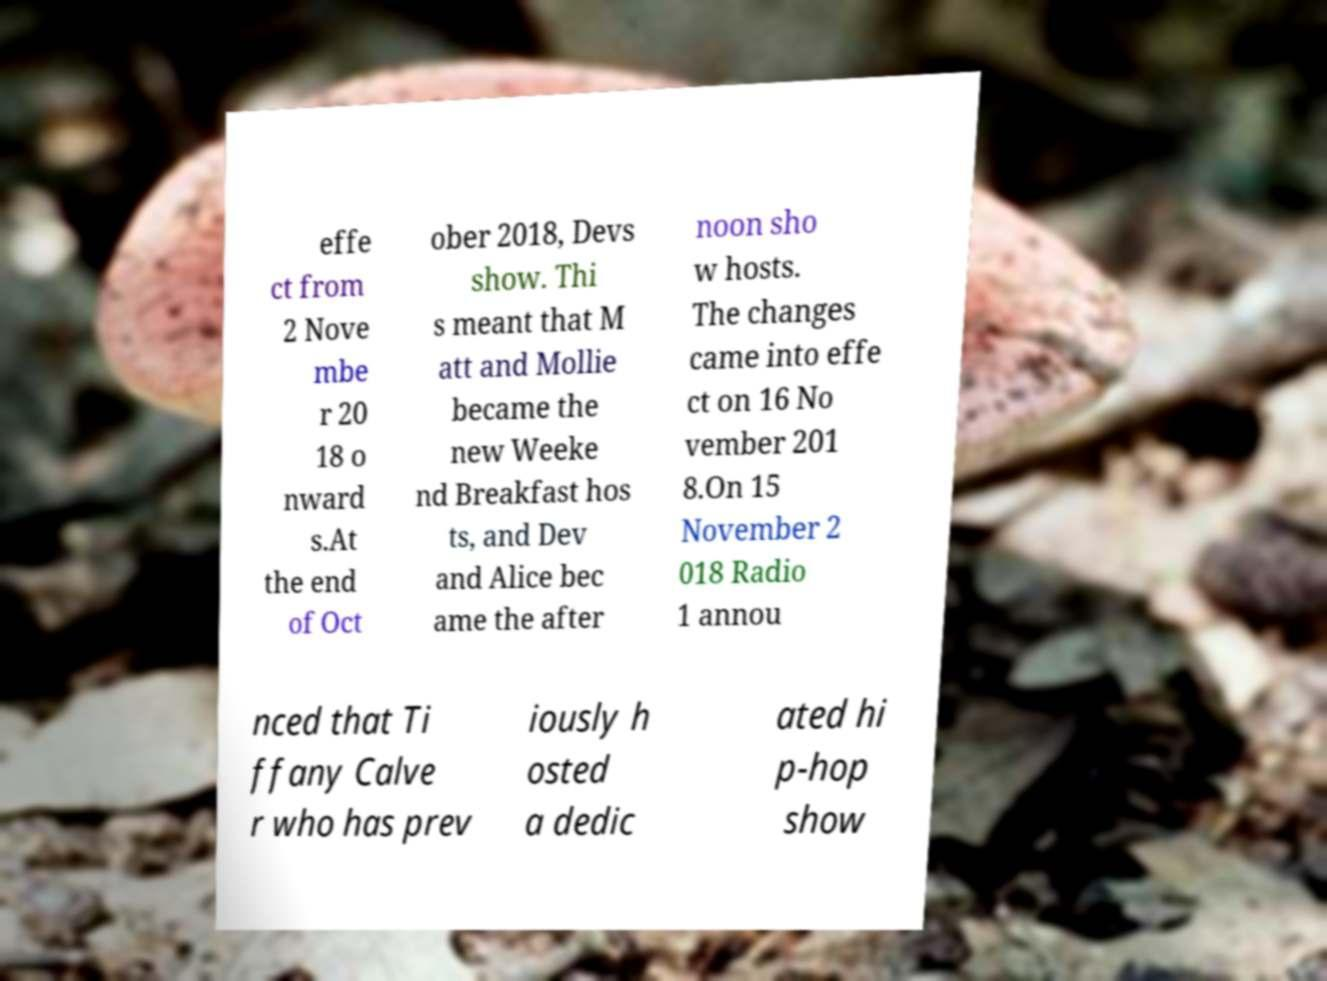For documentation purposes, I need the text within this image transcribed. Could you provide that? effe ct from 2 Nove mbe r 20 18 o nward s.At the end of Oct ober 2018, Devs show. Thi s meant that M att and Mollie became the new Weeke nd Breakfast hos ts, and Dev and Alice bec ame the after noon sho w hosts. The changes came into effe ct on 16 No vember 201 8.On 15 November 2 018 Radio 1 annou nced that Ti ffany Calve r who has prev iously h osted a dedic ated hi p-hop show 